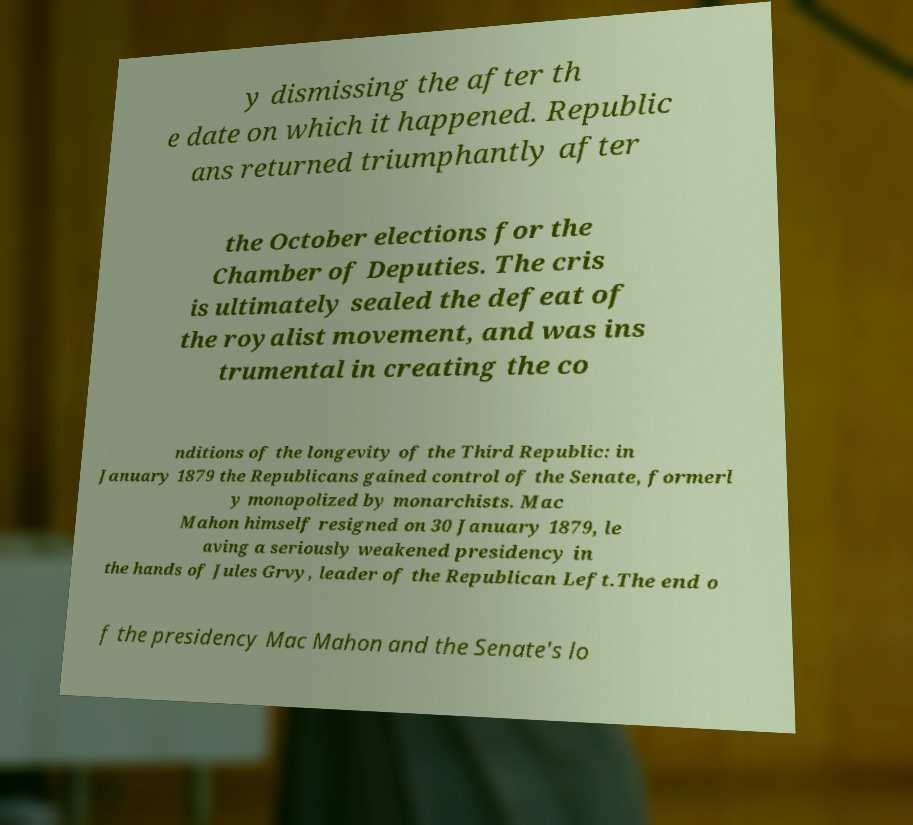Please read and relay the text visible in this image. What does it say? y dismissing the after th e date on which it happened. Republic ans returned triumphantly after the October elections for the Chamber of Deputies. The cris is ultimately sealed the defeat of the royalist movement, and was ins trumental in creating the co nditions of the longevity of the Third Republic: in January 1879 the Republicans gained control of the Senate, formerl y monopolized by monarchists. Mac Mahon himself resigned on 30 January 1879, le aving a seriously weakened presidency in the hands of Jules Grvy, leader of the Republican Left.The end o f the presidency Mac Mahon and the Senate's lo 